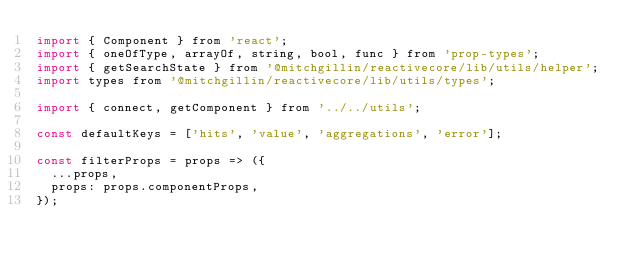Convert code to text. <code><loc_0><loc_0><loc_500><loc_500><_JavaScript_>import { Component } from 'react';
import { oneOfType, arrayOf, string, bool, func } from 'prop-types';
import { getSearchState } from '@mitchgillin/reactivecore/lib/utils/helper';
import types from '@mitchgillin/reactivecore/lib/utils/types';

import { connect, getComponent } from '../../utils';

const defaultKeys = ['hits', 'value', 'aggregations', 'error'];

const filterProps = props => ({
	...props,
	props: props.componentProps,
});
</code> 